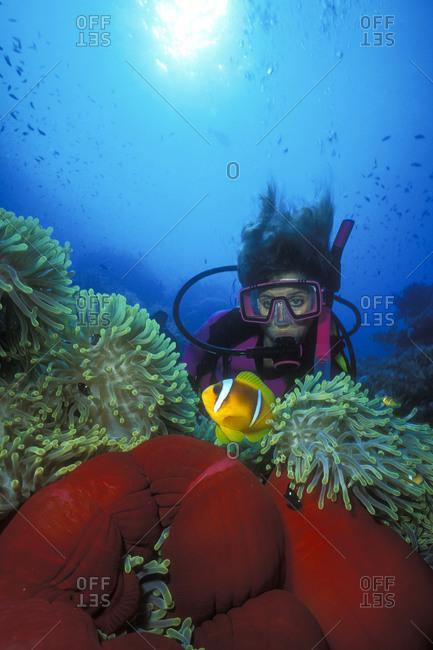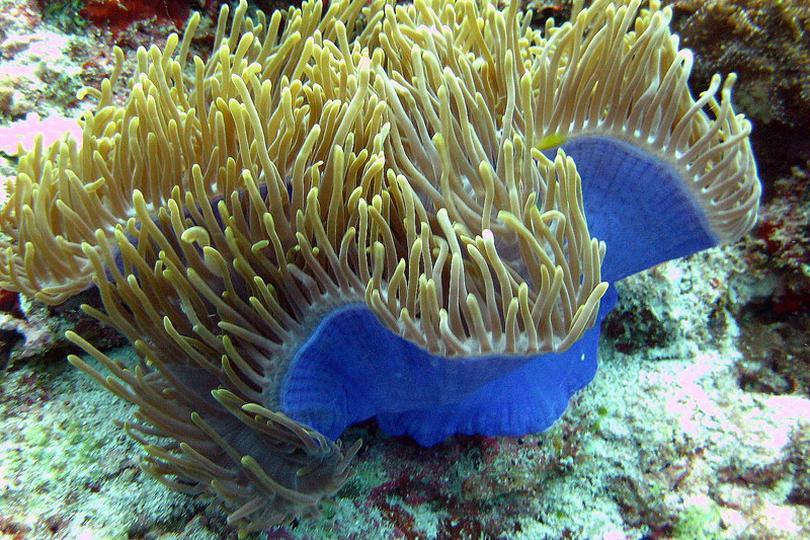The first image is the image on the left, the second image is the image on the right. For the images shown, is this caption "A bright yellow fish is swimming in the water in the image on the left." true? Answer yes or no. Yes. The first image is the image on the left, the second image is the image on the right. Examine the images to the left and right. Is the description "Only one of the images contains clown fish." accurate? Answer yes or no. Yes. 